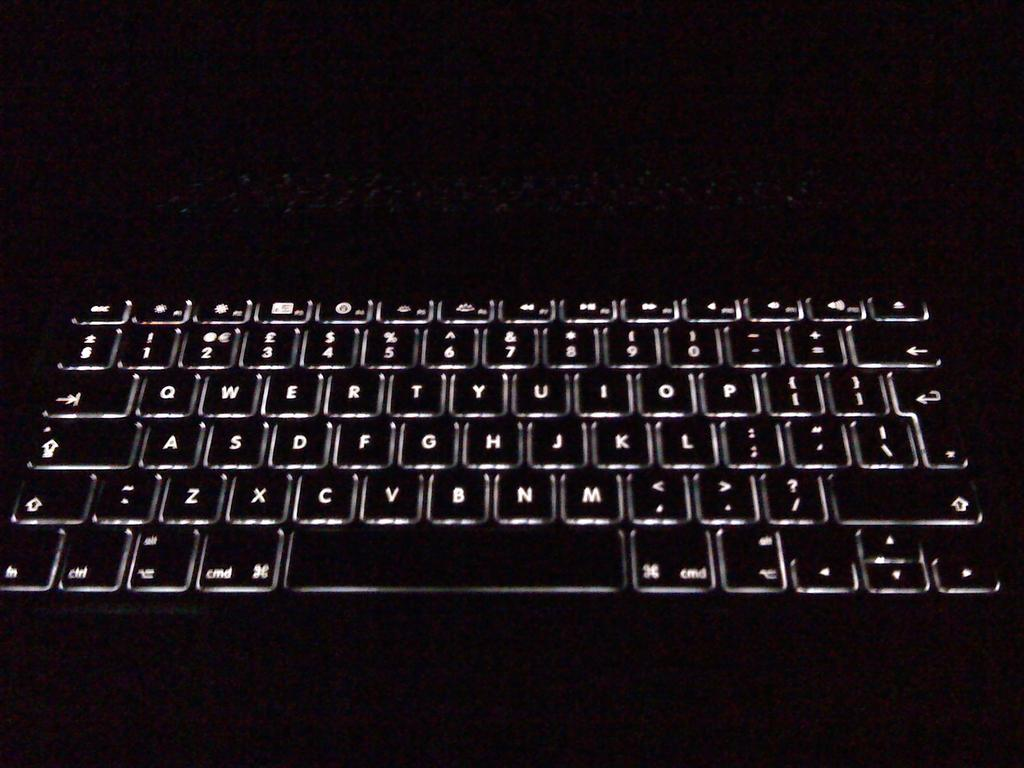<image>
Render a clear and concise summary of the photo. a computer keyboard that has the letter B on it 